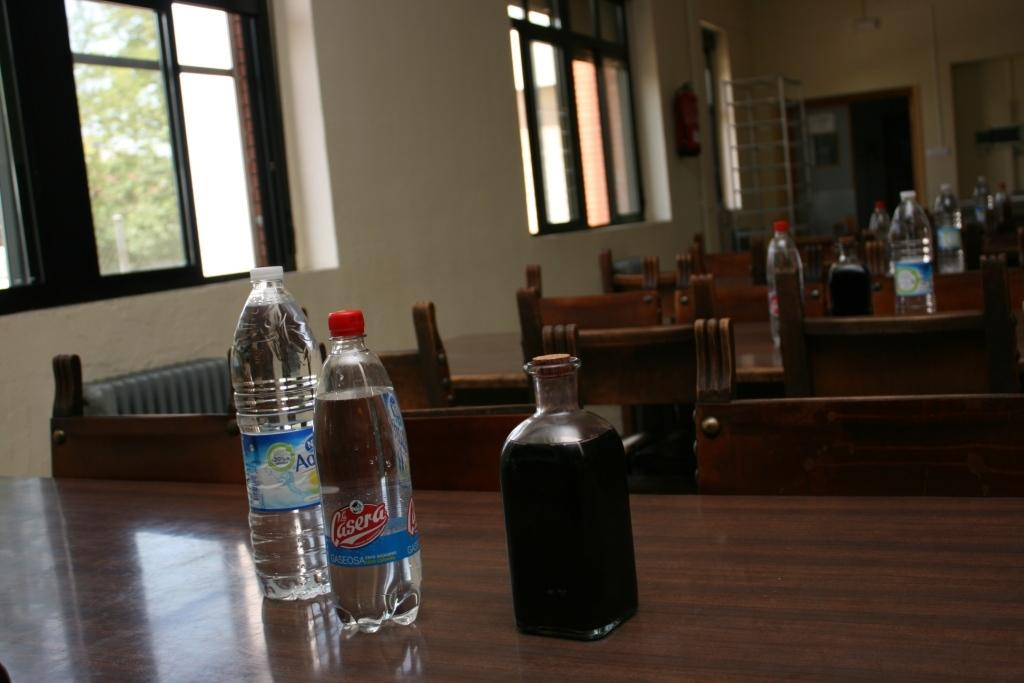<image>
Summarize the visual content of the image. A bottle of Casera is one of the beverages on the desk. 